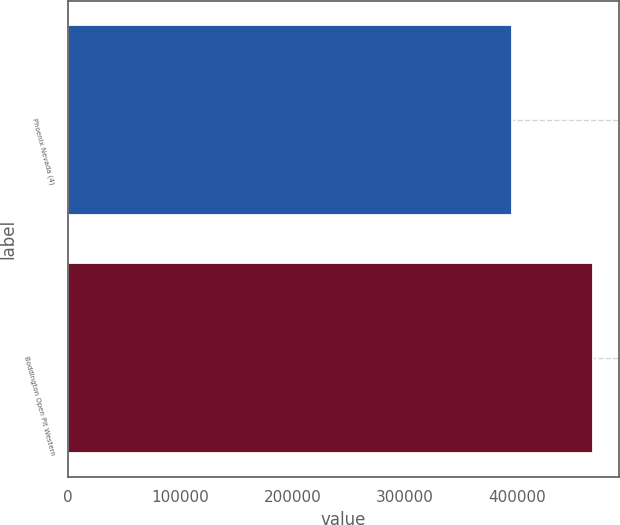<chart> <loc_0><loc_0><loc_500><loc_500><bar_chart><fcel>Phoenix Nevada (4)<fcel>Boddington Open Pit Western<nl><fcel>395500<fcel>467600<nl></chart> 